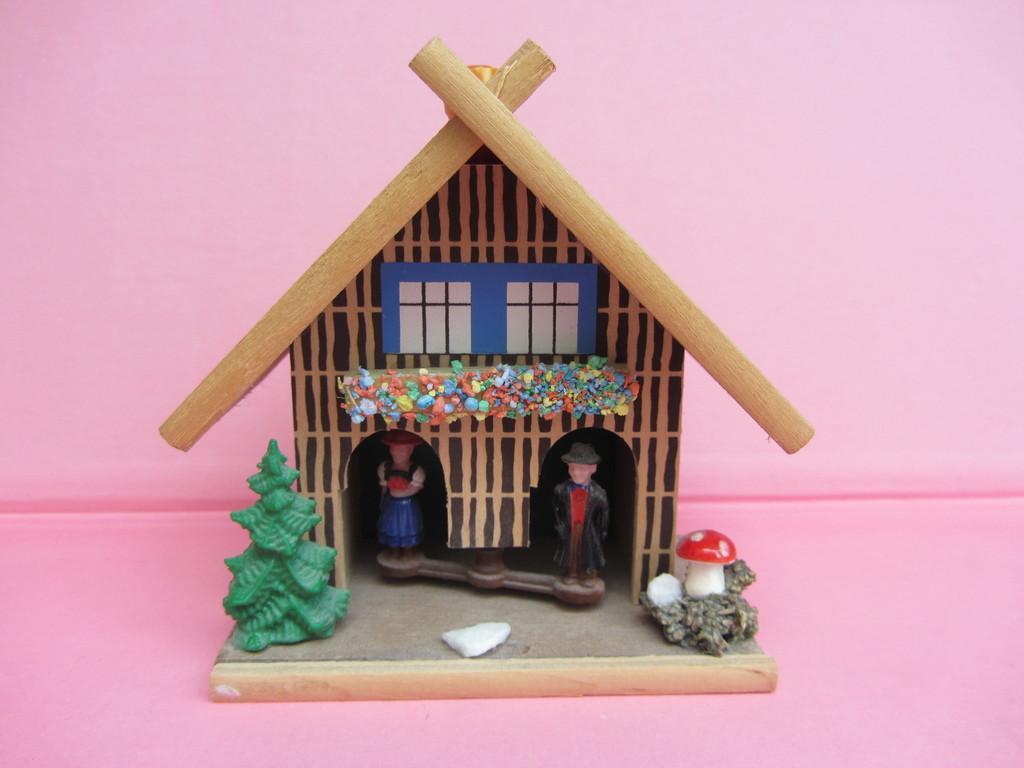Describe this image in one or two sentences. We can see toy house on the pink surface. In the background it is pink. 